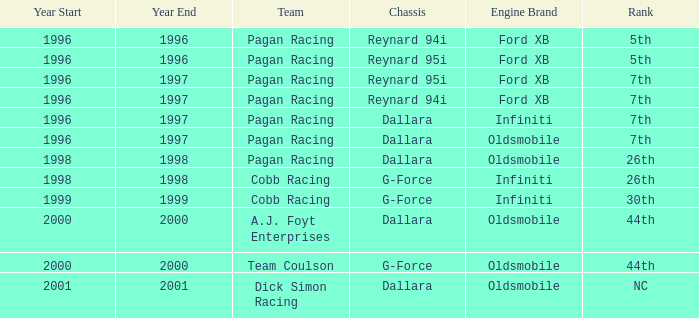What rank did the dallara chassis finish in 2000? 44th. 